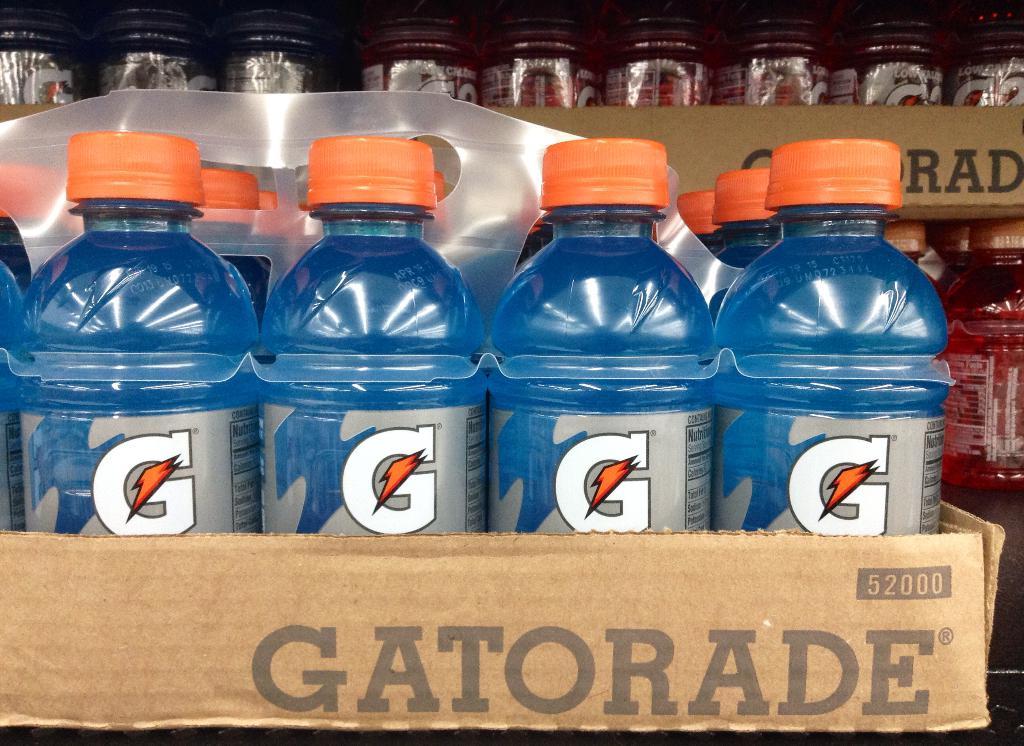What letter is on the label?
Offer a very short reply. G. 